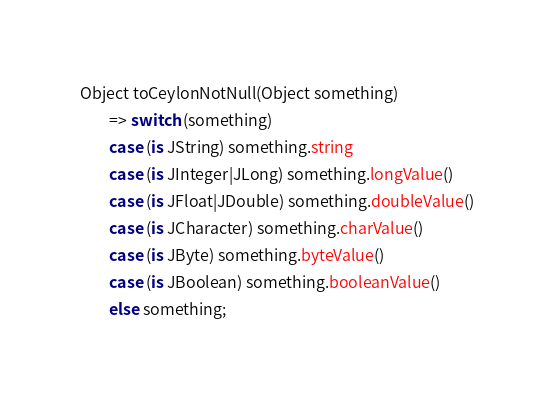<code> <loc_0><loc_0><loc_500><loc_500><_Ceylon_>
Object toCeylonNotNull(Object something)
        => switch (something)
        case (is JString) something.string
        case (is JInteger|JLong) something.longValue()
        case (is JFloat|JDouble) something.doubleValue()
        case (is JCharacter) something.charValue()
        case (is JByte) something.byteValue()
        case (is JBoolean) something.booleanValue()
        else something;</code> 